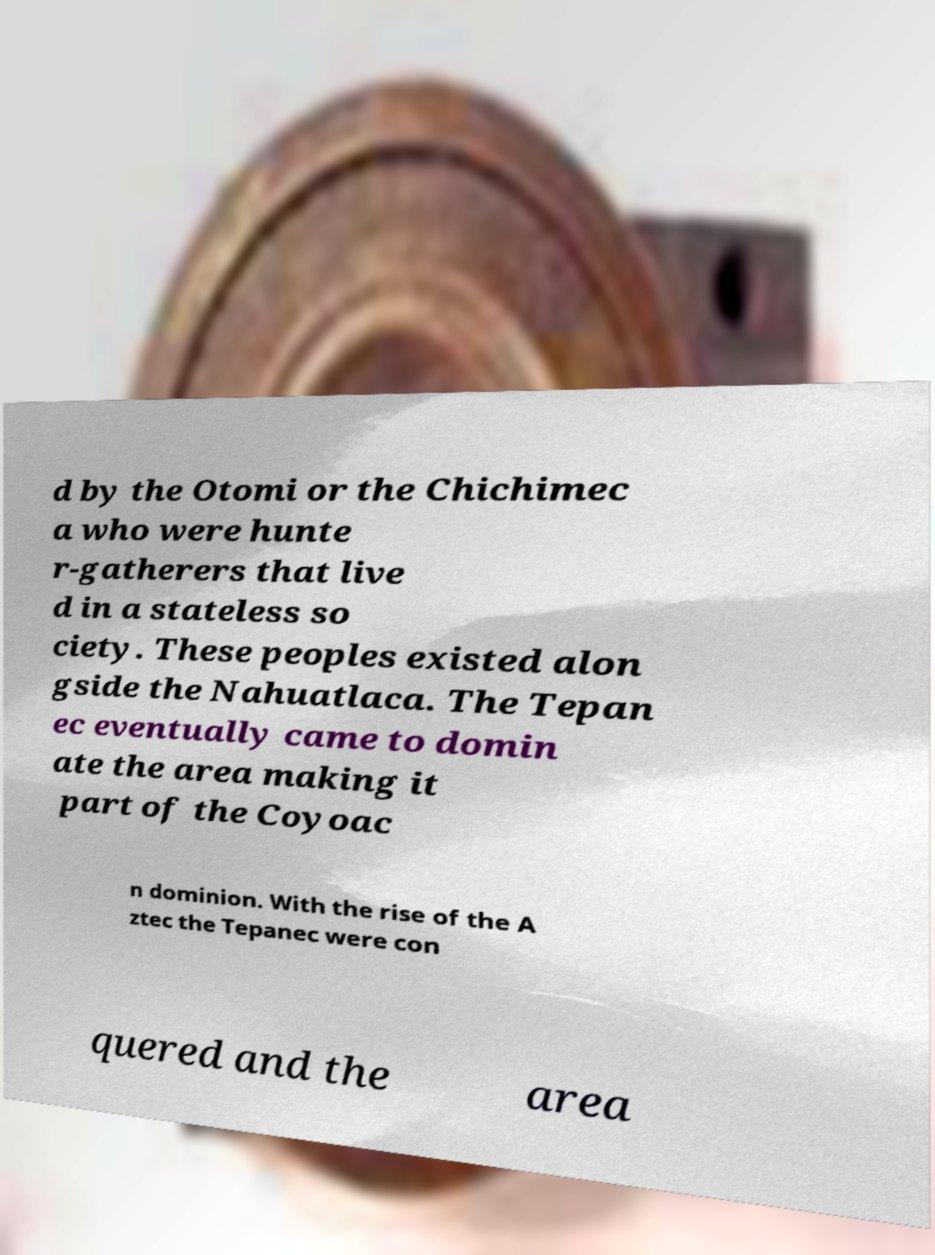For documentation purposes, I need the text within this image transcribed. Could you provide that? d by the Otomi or the Chichimec a who were hunte r-gatherers that live d in a stateless so ciety. These peoples existed alon gside the Nahuatlaca. The Tepan ec eventually came to domin ate the area making it part of the Coyoac n dominion. With the rise of the A ztec the Tepanec were con quered and the area 